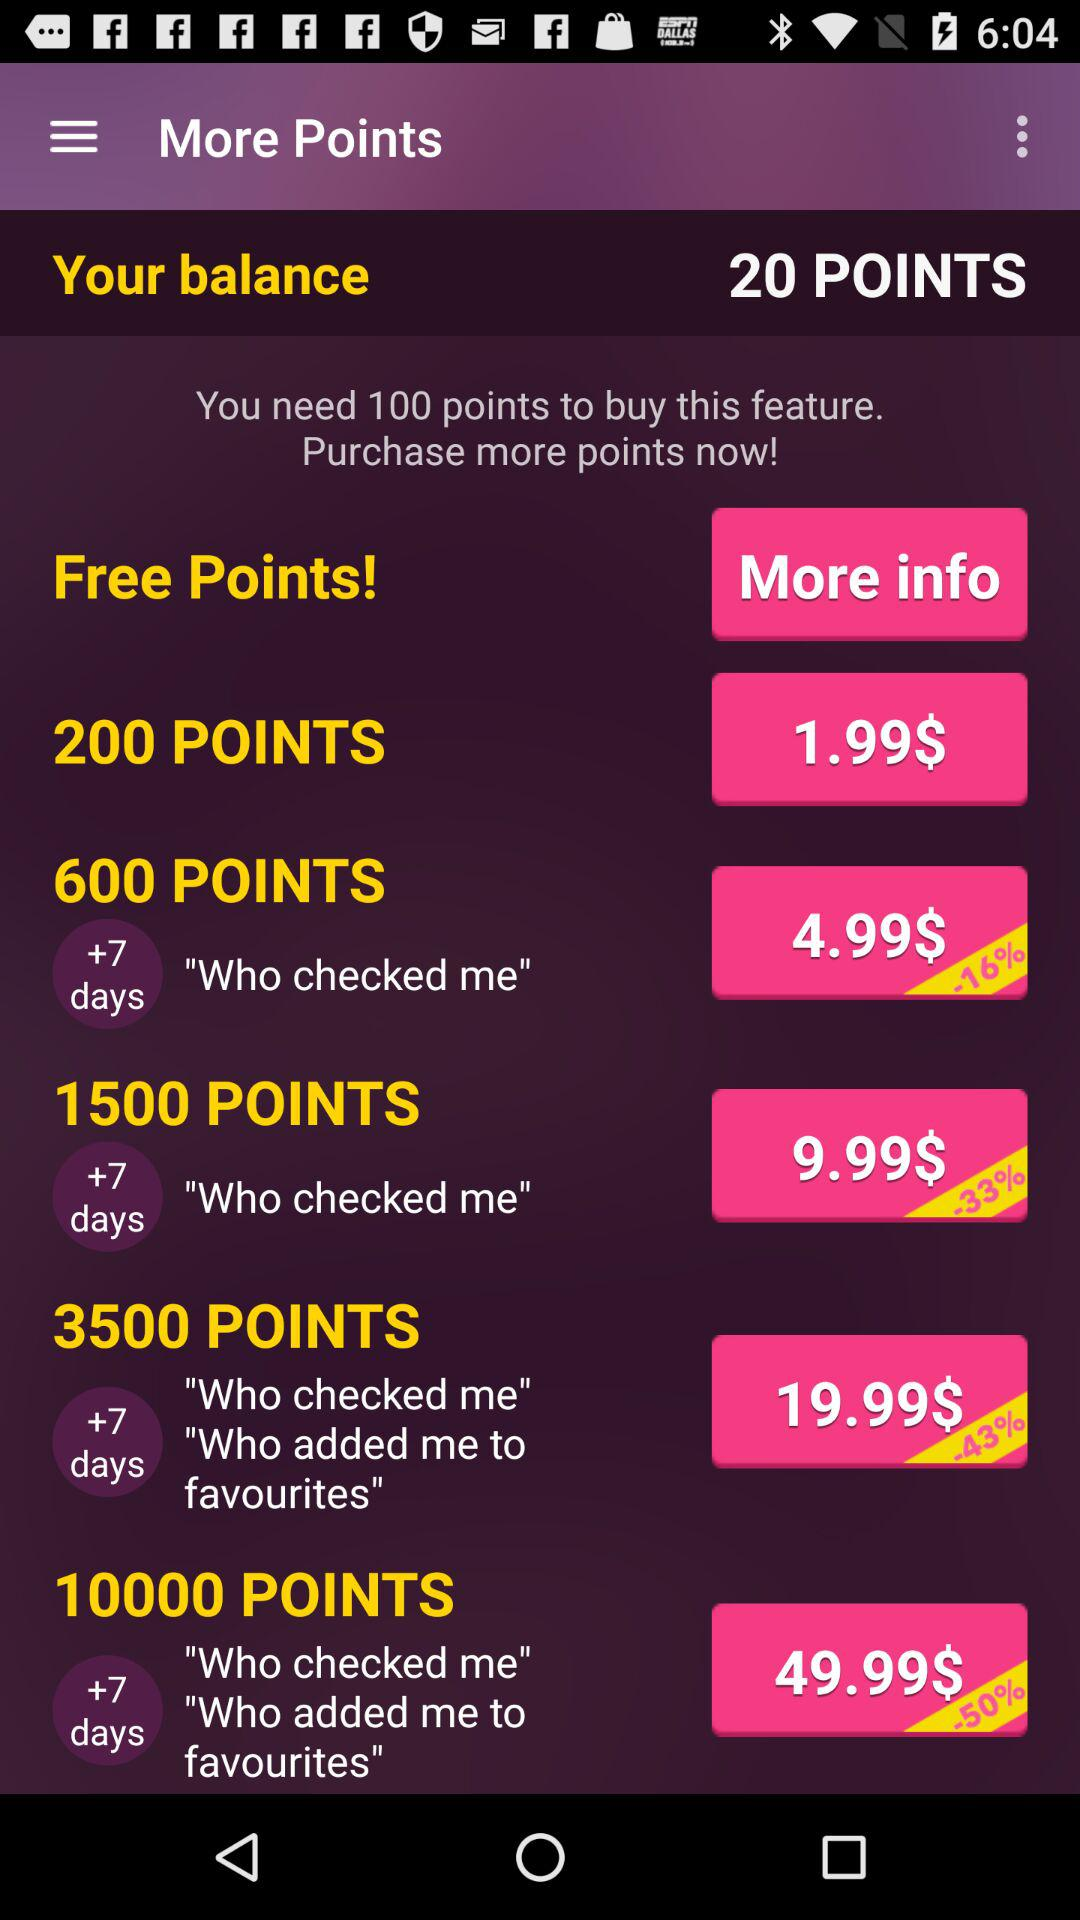What is the balance? The balance is 20 points. 